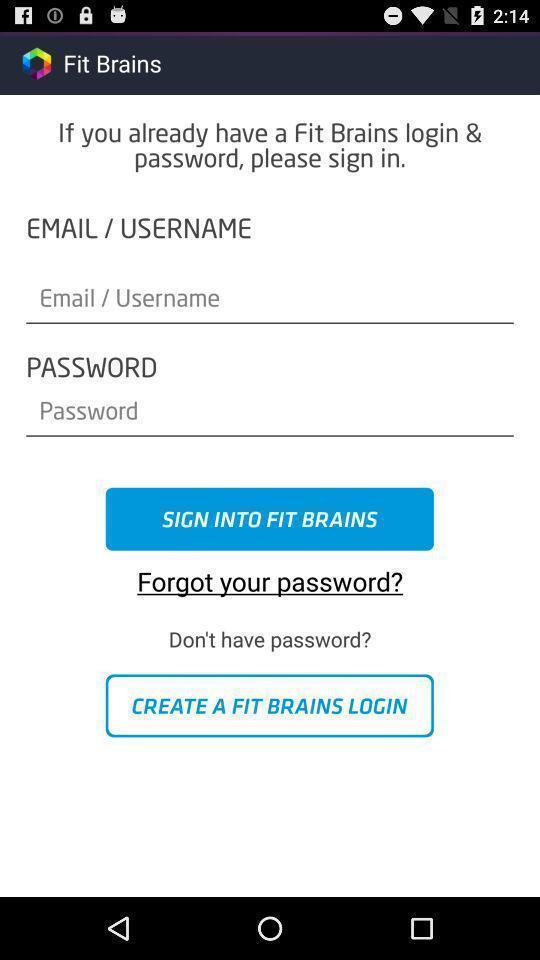Give me a narrative description of this picture. Sign in page of the application to get access. 